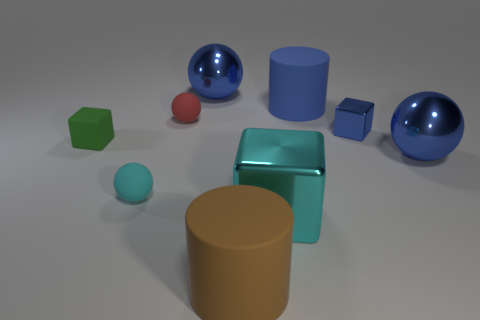There is a metal block to the right of the cylinder that is behind the cylinder that is in front of the tiny cyan ball; what is its size?
Ensure brevity in your answer.  Small. The rubber thing that is the same shape as the large cyan metal thing is what size?
Your response must be concise. Small. How many things are the same color as the small metallic block?
Keep it short and to the point. 3. There is a brown cylinder; is it the same size as the cube left of the red rubber object?
Give a very brief answer. No. What material is the big blue object on the left side of the big cyan metal thing?
Offer a very short reply. Metal. There is another block that is made of the same material as the tiny blue cube; what color is it?
Offer a terse response. Cyan. What number of metal objects are blue cylinders or small things?
Keep it short and to the point. 1. What is the shape of the cyan object that is the same size as the brown matte cylinder?
Your answer should be very brief. Cube. How many objects are either tiny things that are behind the cyan sphere or large rubber cylinders behind the tiny cyan object?
Your response must be concise. 4. There is a red thing that is the same size as the matte cube; what material is it?
Offer a terse response. Rubber. 